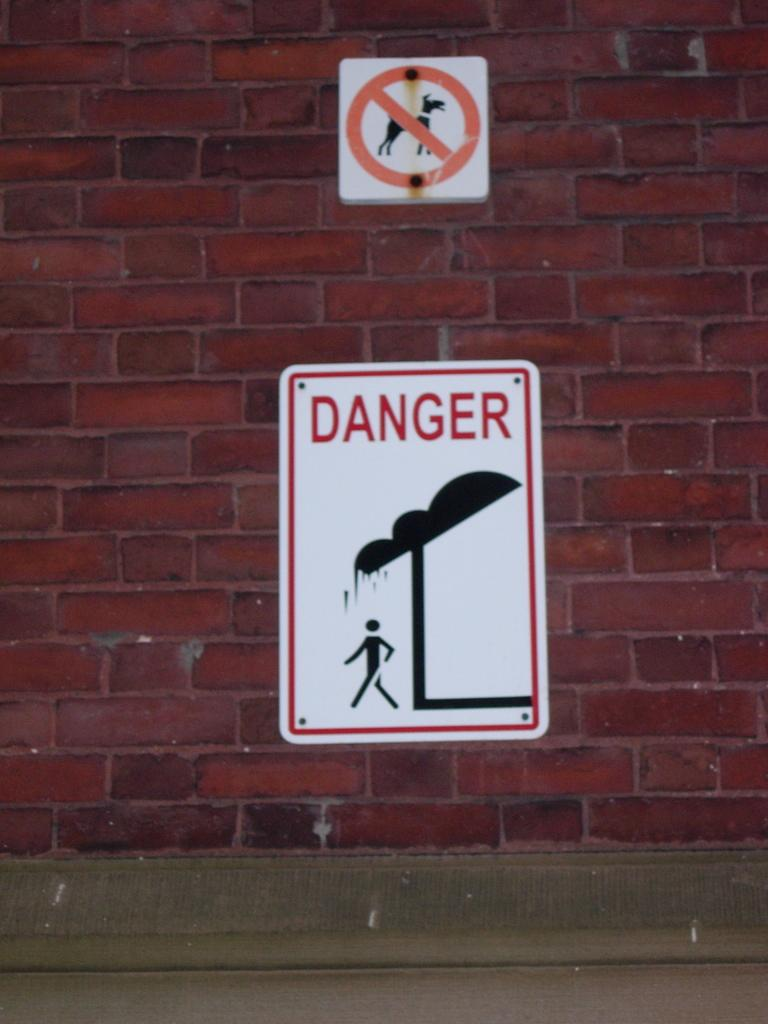What can be seen on the wall in the image? There are sign boards on the wall in the image. Can you describe the sign boards? The provided facts do not give any details about the sign boards, so we cannot describe them. What type of sand can be seen on the floor in the image? There is no sand present in the image; it only shows sign boards on the wall. 